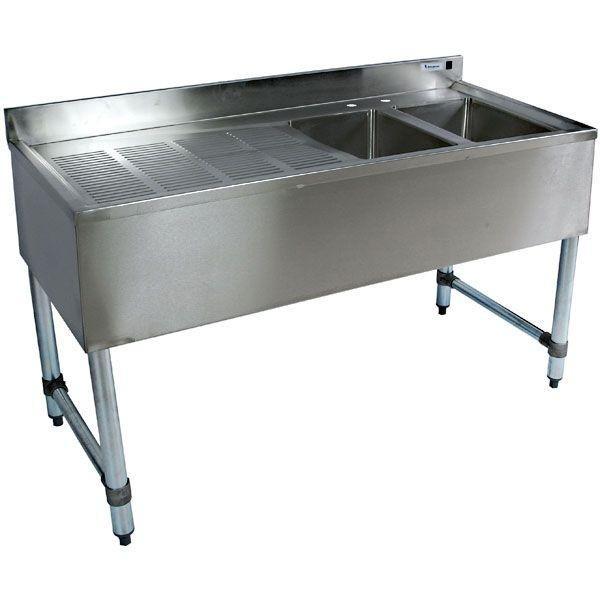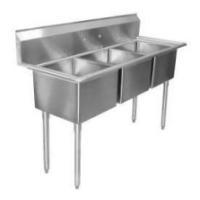The first image is the image on the left, the second image is the image on the right. For the images shown, is this caption "Two silvery metal prep sinks stand on legs, and each has two or more sink bowls." true? Answer yes or no. Yes. 